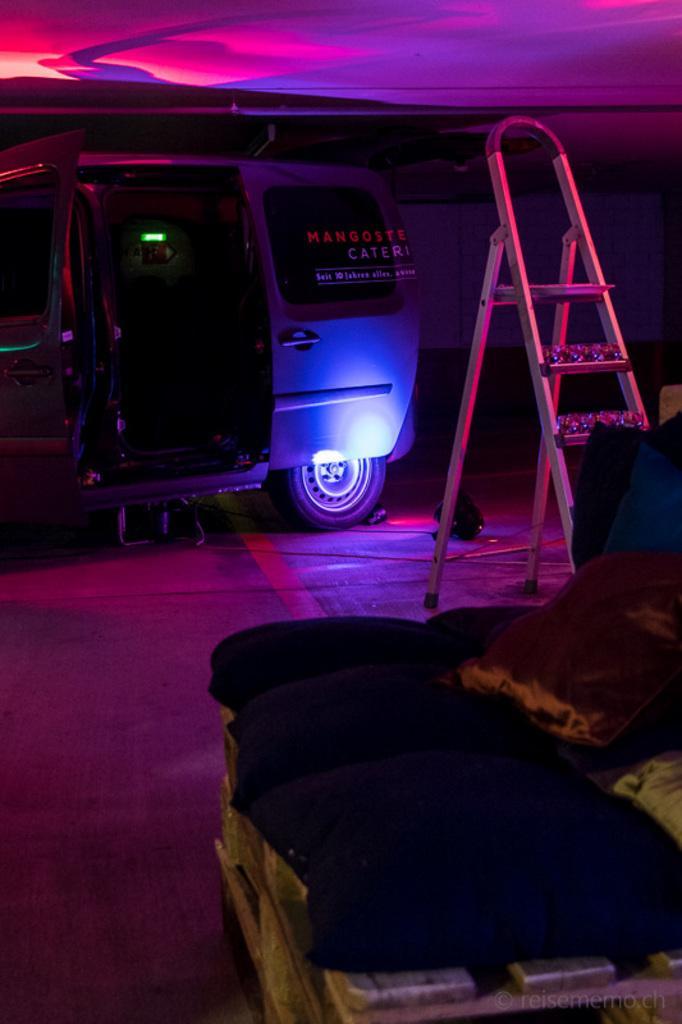Could you give a brief overview of what you see in this image? In this image I can see a cushion which is brown in color, few black colored pillows, a vehicle on the ground, a ladder and the light. I can see the pink colored light on the ceiling. 